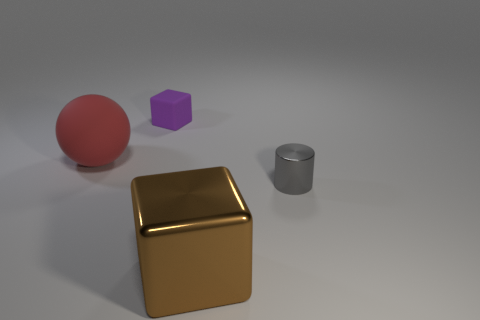Is there a purple cube of the same size as the cylinder?
Offer a very short reply. Yes. What color is the object in front of the small thing in front of the small purple rubber object?
Keep it short and to the point. Brown. What number of blue cylinders are there?
Your answer should be compact. 0. Is the color of the metal cylinder the same as the small block?
Ensure brevity in your answer.  No. Are there fewer tiny purple cubes that are on the left side of the metal cylinder than spheres behind the large brown shiny thing?
Provide a succinct answer. No. What color is the large metal thing?
Ensure brevity in your answer.  Brown. What number of large balls have the same color as the big cube?
Your response must be concise. 0. There is a large metal cube; are there any shiny cubes on the left side of it?
Your answer should be very brief. No. Are there an equal number of small gray metallic things that are in front of the big matte sphere and spheres that are right of the matte block?
Give a very brief answer. No. There is a cube in front of the purple matte object; is its size the same as the rubber object to the left of the purple cube?
Your response must be concise. Yes. 